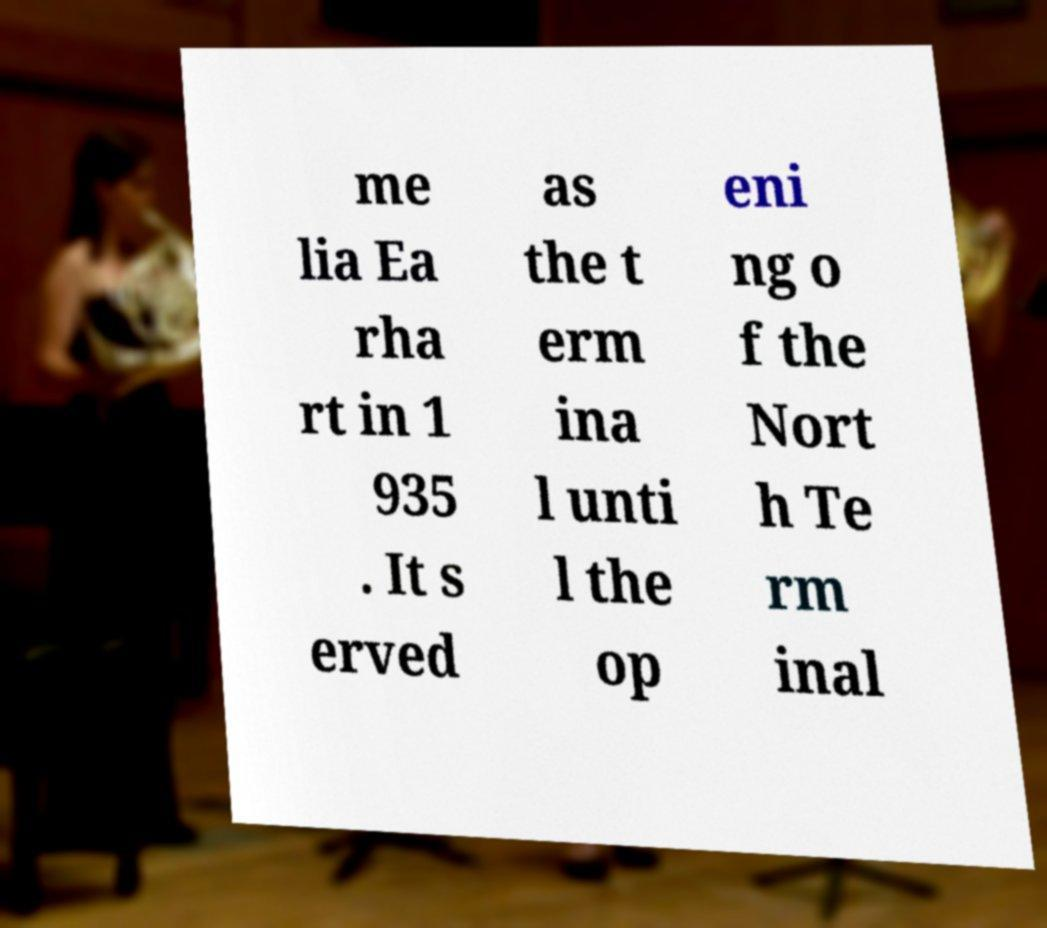I need the written content from this picture converted into text. Can you do that? me lia Ea rha rt in 1 935 . It s erved as the t erm ina l unti l the op eni ng o f the Nort h Te rm inal 